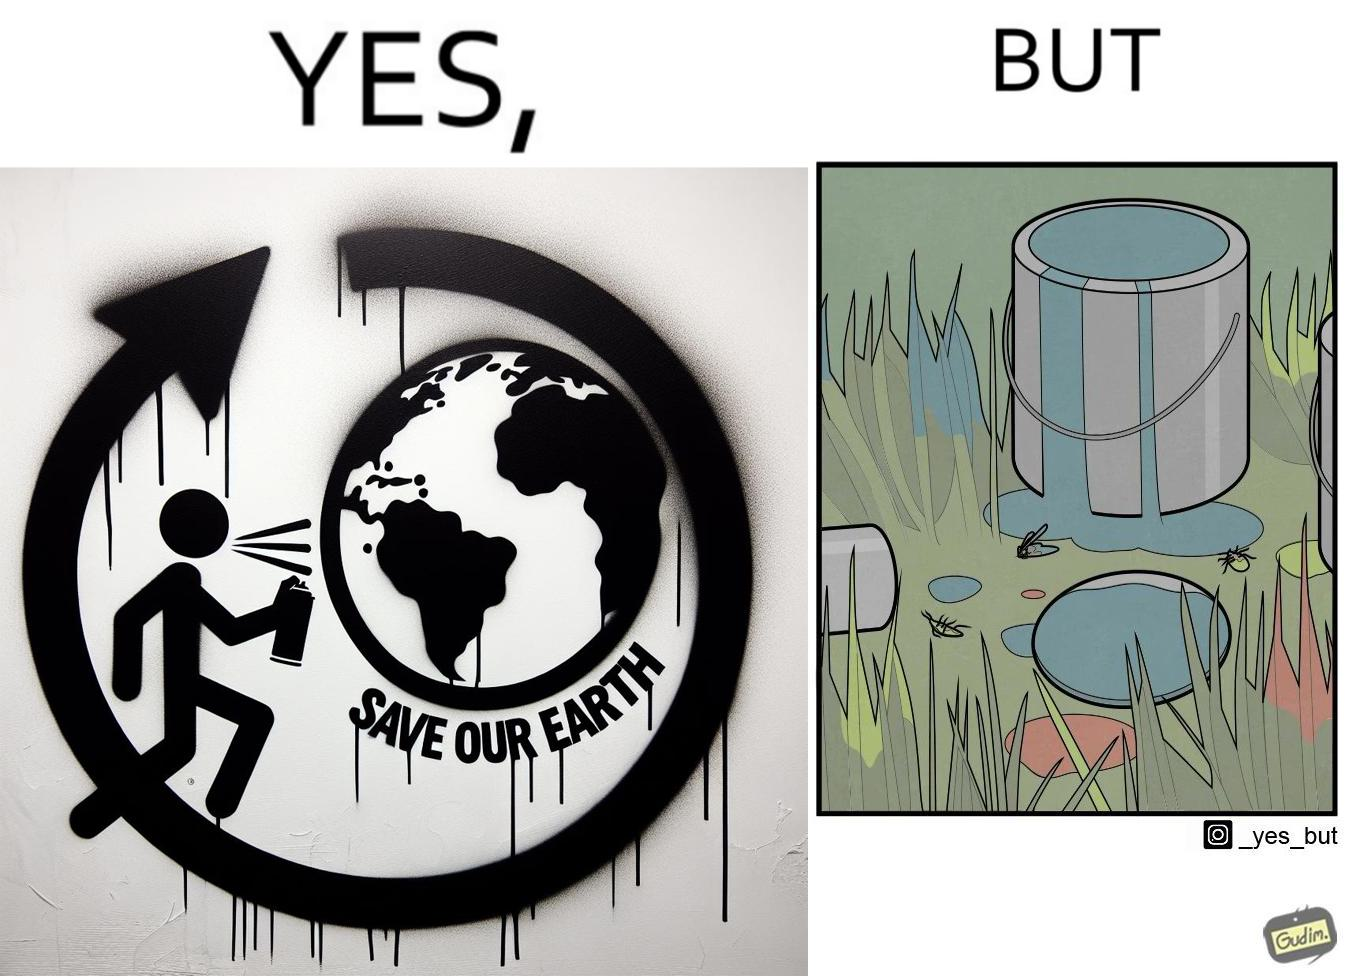Is this a satirical image? Yes, this image is satirical. 